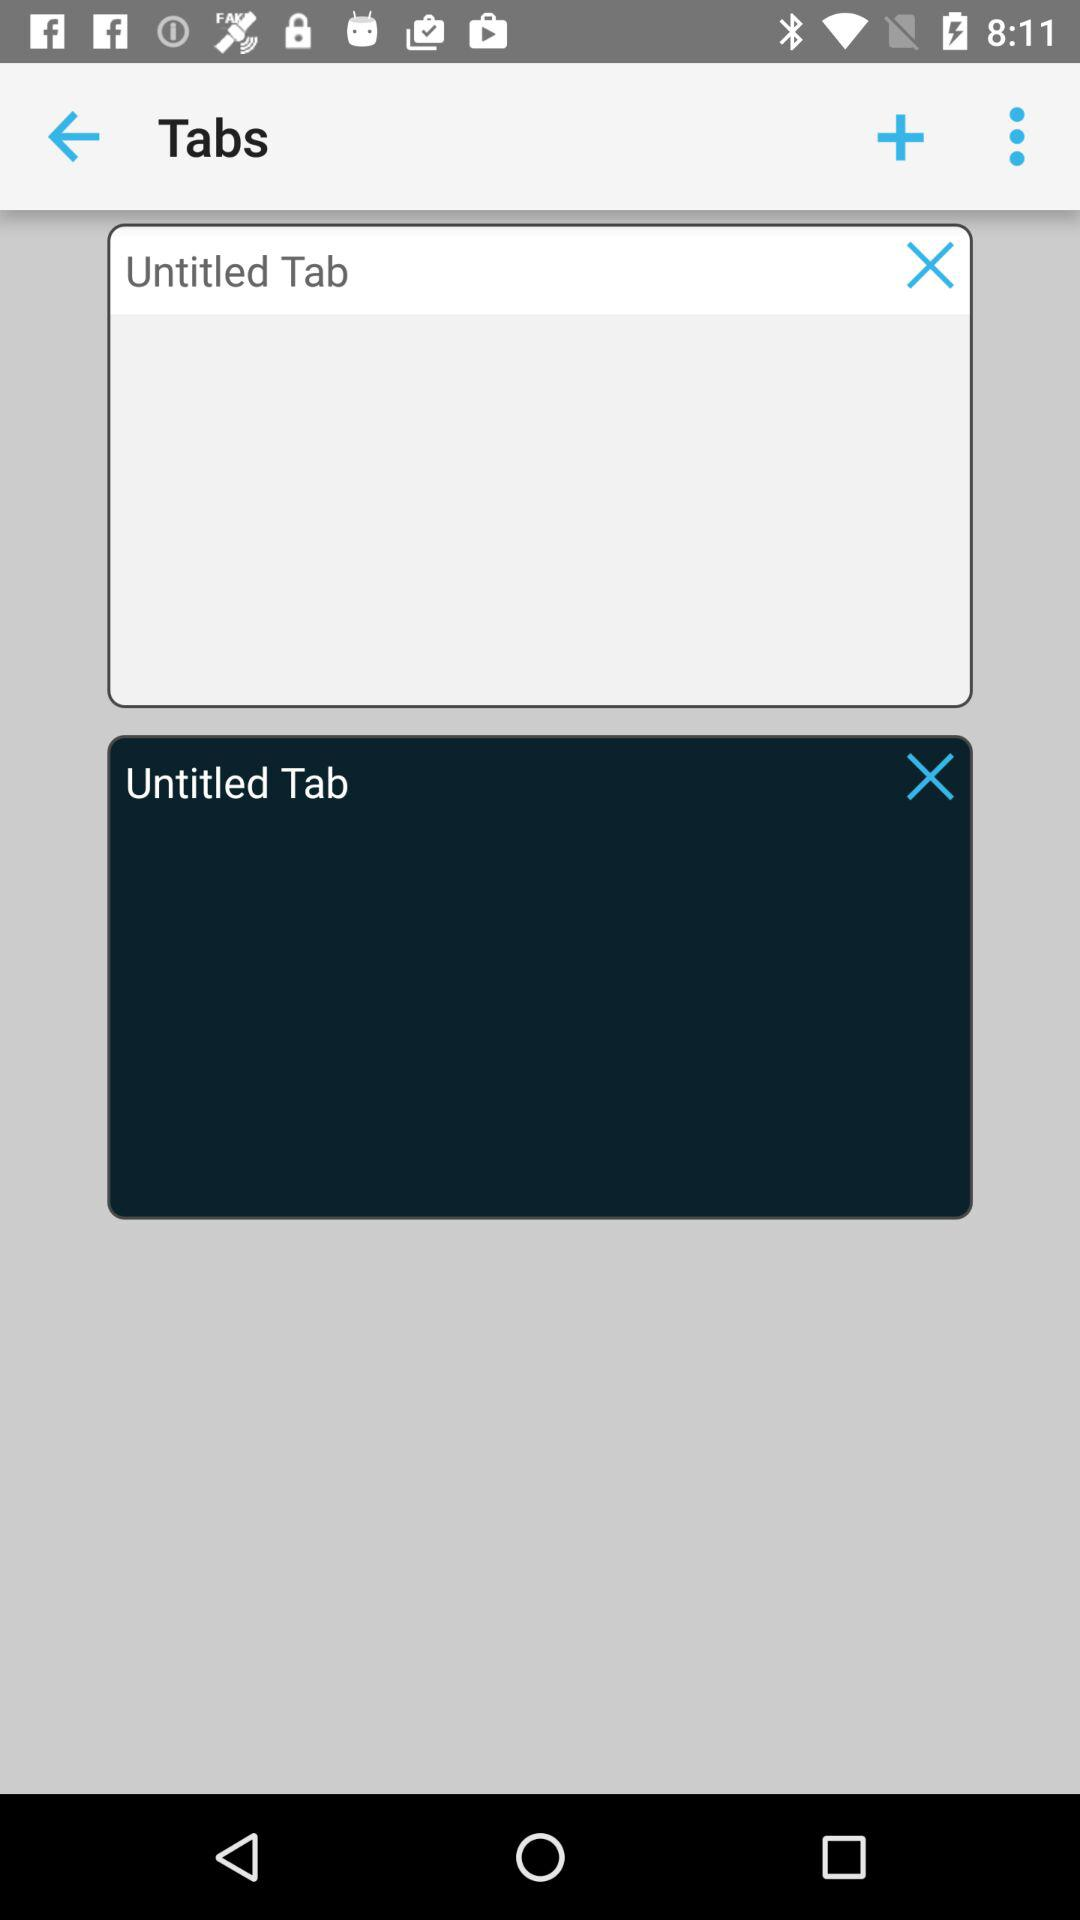How many tabs are there with the text 'Untitled Tab'?
Answer the question using a single word or phrase. 2 